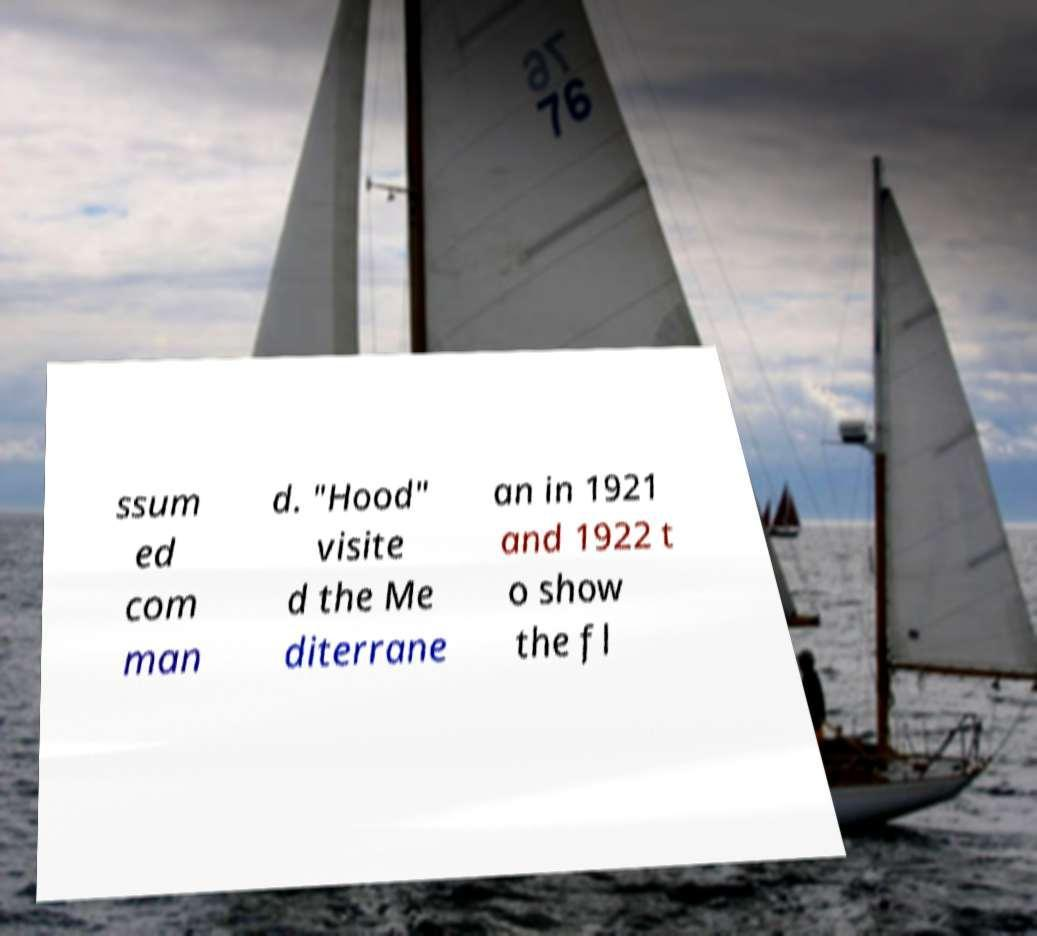Please read and relay the text visible in this image. What does it say? ssum ed com man d. "Hood" visite d the Me diterrane an in 1921 and 1922 t o show the fl 